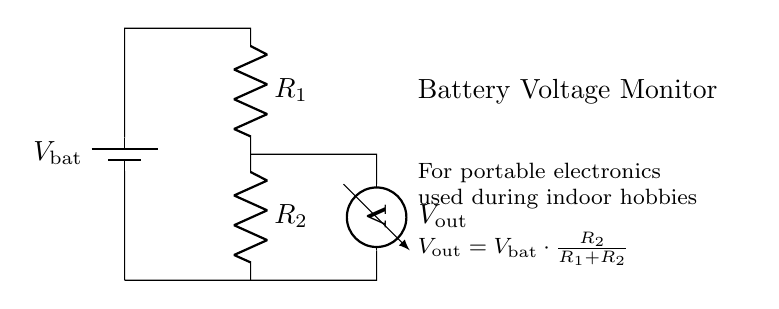What is the source voltage? The source voltage is the voltage of the battery, denoted as V bat in the circuit. It is indicated as the topmost component in the diagram.
Answer: V bat What type of circuit is this? This is a voltage divider circuit, as evidenced by the arrangement of resistors R1 and R2, which split the input voltage across them.
Answer: Voltage divider What does V out represent? V out represents the output voltage obtained from the voltage divider, calculated using the formula shown in the diagram, indicating the voltage drop across resistor R2.
Answer: Output voltage How is V out calculated? V out is calculated by using the formula given in the circuit: V out equals V bat multiplied by the fraction of R2 over the sum of R1 and R2. This relationship defines how voltage is divided in the circuit.
Answer: V bat times R2 over R1 plus R2 What happens to V out if R2 is increased? If R2 is increased while R1 remains constant, V out will also increase since the fraction of R2 to the total resistance (R1 + R2) becomes larger, resulting in more voltage across R2.
Answer: V out increases Which component measures V out? The component that measures V out in this circuit is the voltmeter, which is connected across R2. This indicates it is specifically set to measure the voltage drop across that resistor.
Answer: Voltmeter 